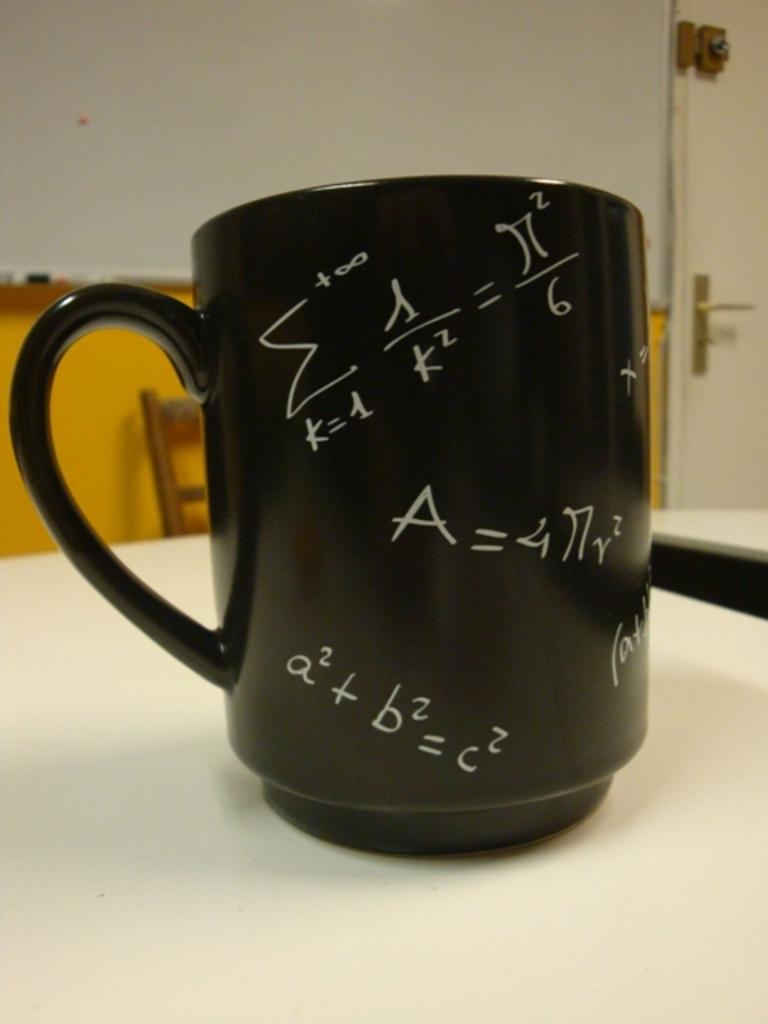<image>
Relay a brief, clear account of the picture shown. A mug with various formulas including a2 + b2 = c2 